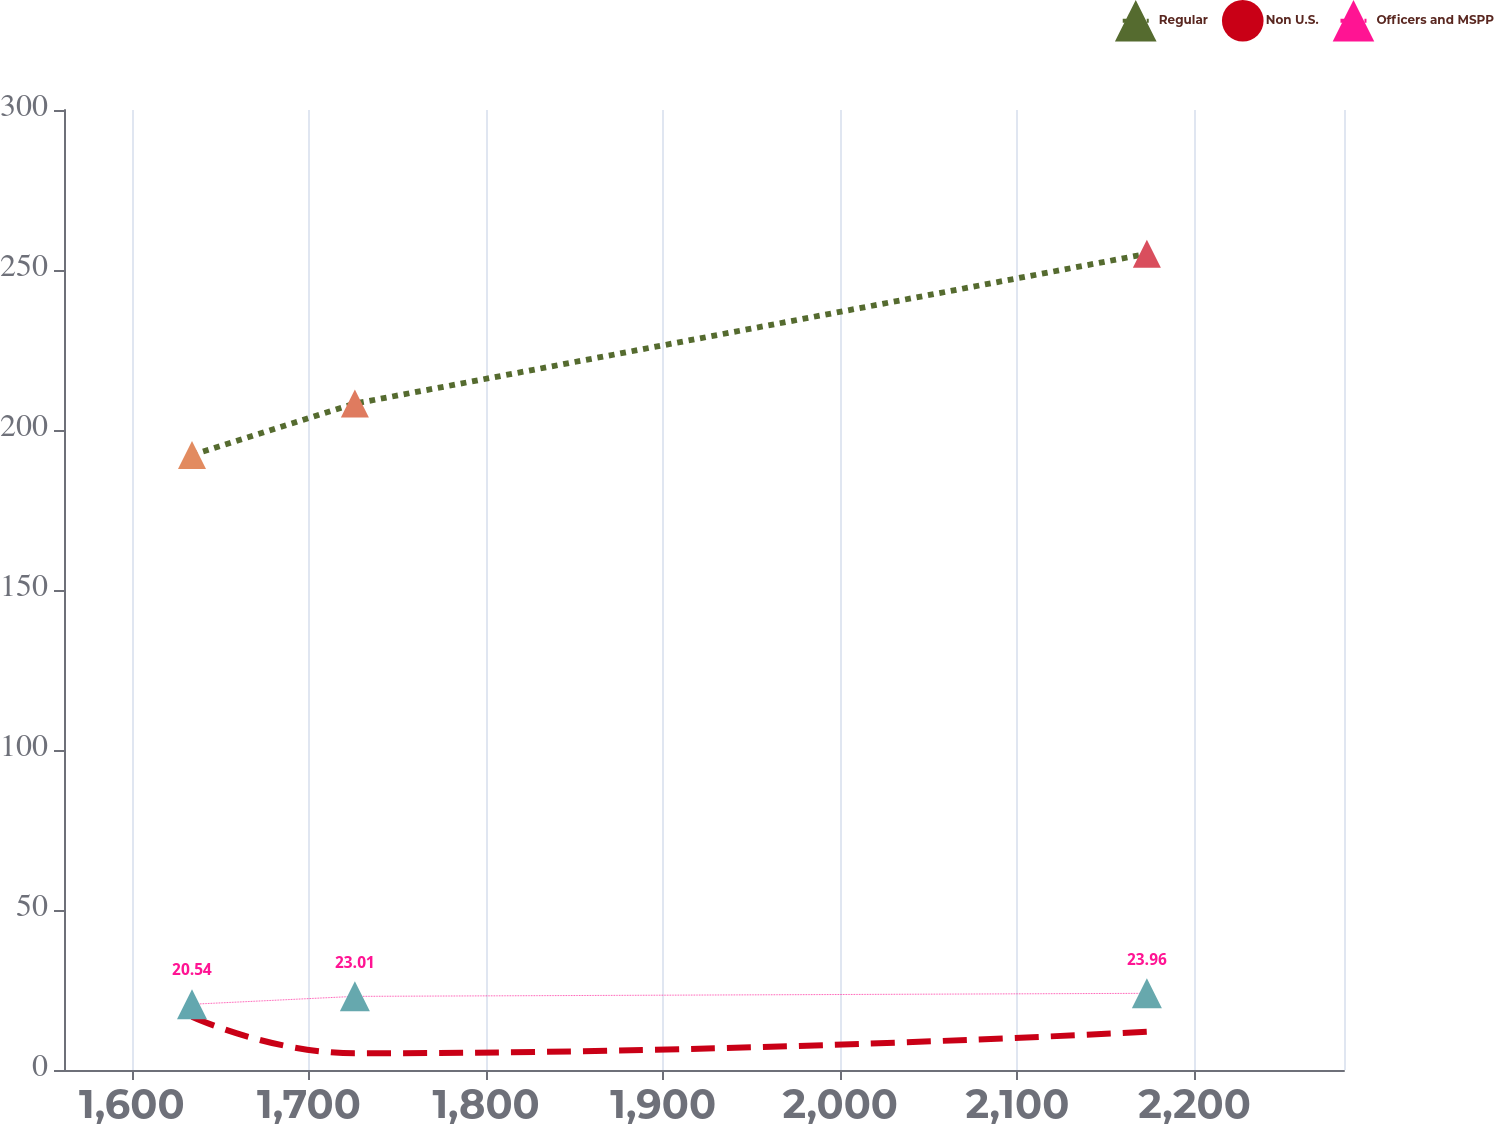Convert chart to OTSL. <chart><loc_0><loc_0><loc_500><loc_500><line_chart><ecel><fcel>Regular<fcel>Non U.S.<fcel>Officers and MSPP<nl><fcel>1633.97<fcel>192.21<fcel>16.66<fcel>20.54<nl><fcel>1725.94<fcel>208.26<fcel>5.21<fcel>23.01<nl><fcel>2173.1<fcel>255.06<fcel>11.96<fcel>23.96<nl><fcel>2290.94<fcel>198.5<fcel>18.52<fcel>28.59<nl><fcel>2356.65<fcel>219.71<fcel>23.77<fcel>24.77<nl></chart> 